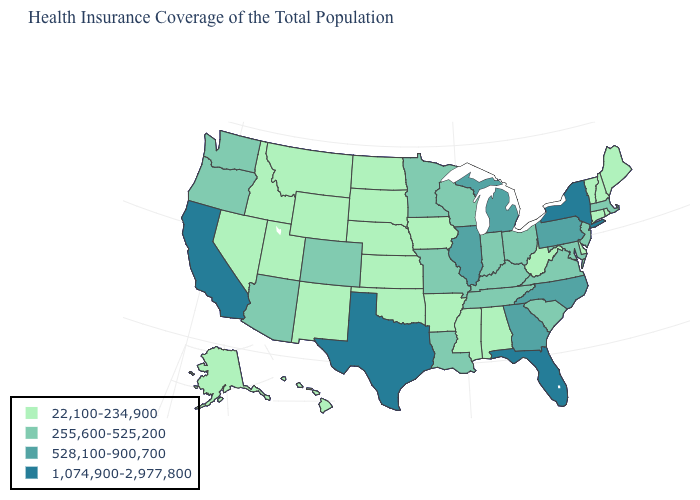Is the legend a continuous bar?
Concise answer only. No. What is the highest value in the USA?
Write a very short answer. 1,074,900-2,977,800. What is the value of New Mexico?
Be succinct. 22,100-234,900. What is the value of West Virginia?
Quick response, please. 22,100-234,900. Does Alabama have a lower value than North Carolina?
Short answer required. Yes. Among the states that border New York , which have the highest value?
Keep it brief. Pennsylvania. Which states have the highest value in the USA?
Concise answer only. California, Florida, New York, Texas. Name the states that have a value in the range 255,600-525,200?
Answer briefly. Arizona, Colorado, Indiana, Kentucky, Louisiana, Maryland, Massachusetts, Minnesota, Missouri, New Jersey, Ohio, Oregon, South Carolina, Tennessee, Virginia, Washington, Wisconsin. What is the value of North Carolina?
Write a very short answer. 528,100-900,700. What is the value of Wyoming?
Quick response, please. 22,100-234,900. Which states have the highest value in the USA?
Answer briefly. California, Florida, New York, Texas. Which states have the lowest value in the USA?
Short answer required. Alabama, Alaska, Arkansas, Connecticut, Delaware, Hawaii, Idaho, Iowa, Kansas, Maine, Mississippi, Montana, Nebraska, Nevada, New Hampshire, New Mexico, North Dakota, Oklahoma, Rhode Island, South Dakota, Utah, Vermont, West Virginia, Wyoming. What is the value of South Carolina?
Keep it brief. 255,600-525,200. What is the value of Pennsylvania?
Write a very short answer. 528,100-900,700. What is the value of Arkansas?
Answer briefly. 22,100-234,900. 